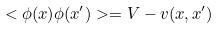<formula> <loc_0><loc_0><loc_500><loc_500>< \phi ( x ) \phi ( x ^ { \prime } ) > = V - v ( x , x ^ { \prime } )</formula> 